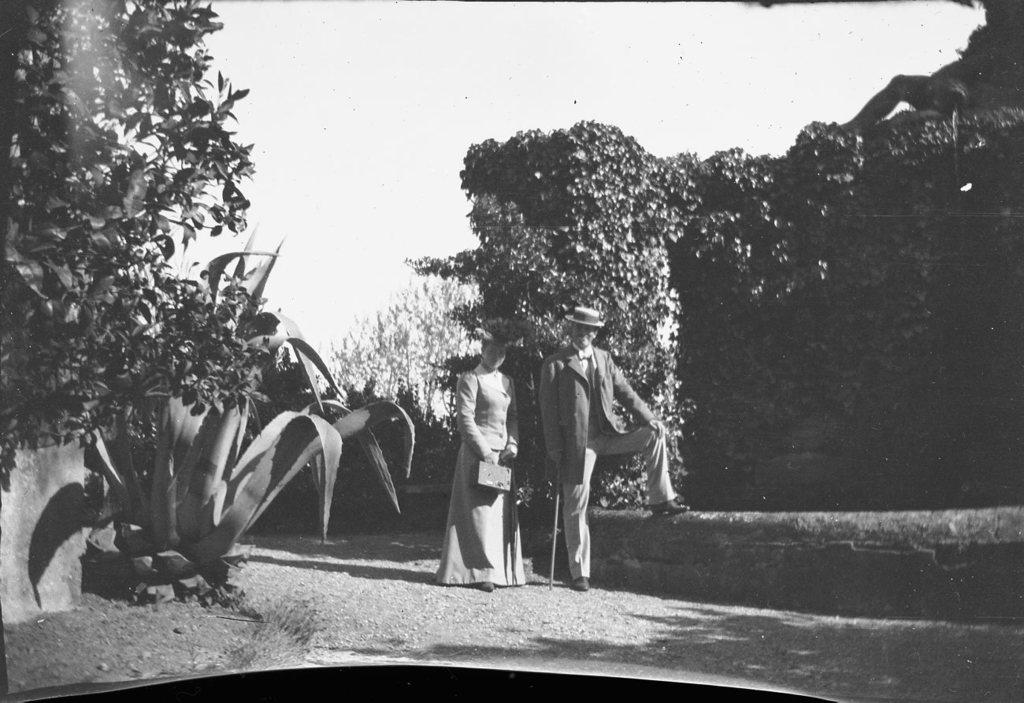What is the main subject of the image? There is an old photograph in the image. Who or what is featured in the photograph? The photograph features a couple. What are the couple doing in the photograph? The couple is standing and posing for the camera. What is the emotional expression of the couple in the photograph? The couple is smiling in the photograph. What can be seen in the background of the photograph? There are trees around the couple in the photograph. What type of game is the person playing in the image? There is no person playing a game in the image; it features an old photograph of a couple. 